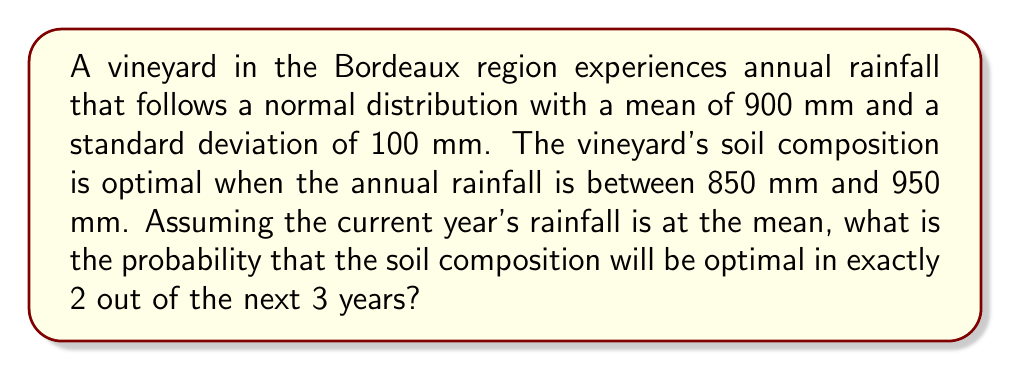Can you answer this question? Let's approach this step-by-step:

1) First, we need to calculate the probability of optimal soil composition in a single year. This occurs when the rainfall is between 850 mm and 950 mm.

2) We can standardize these values:
   For 850 mm: $z_1 = \frac{850 - 900}{100} = -0.5$
   For 950 mm: $z_2 = \frac{950 - 900}{100} = 0.5$

3) The probability of optimal soil composition in a single year is:
   $P(\text{optimal}) = P(-0.5 < Z < 0.5) = \Phi(0.5) - \Phi(-0.5)$
   where $\Phi$ is the standard normal cumulative distribution function.

4) Using a standard normal table or calculator:
   $P(\text{optimal}) = 0.6915 - 0.3085 = 0.3830$

5) Let $p = 0.3830$ be the probability of success (optimal soil composition) in a single year.

6) We want the probability of exactly 2 successes in 3 trials, which follows a binomial distribution:
   $$P(X = 2) = \binom{3}{2} p^2 (1-p)^1$$

7) Calculating:
   $$P(X = 2) = 3 \cdot (0.3830)^2 \cdot (0.6170)^1 = 3 \cdot 0.1467 \cdot 0.6170 = 0.2716$$

Therefore, the probability of optimal soil composition in exactly 2 out of the next 3 years is approximately 0.2716 or 27.16%.
Answer: 0.2716 